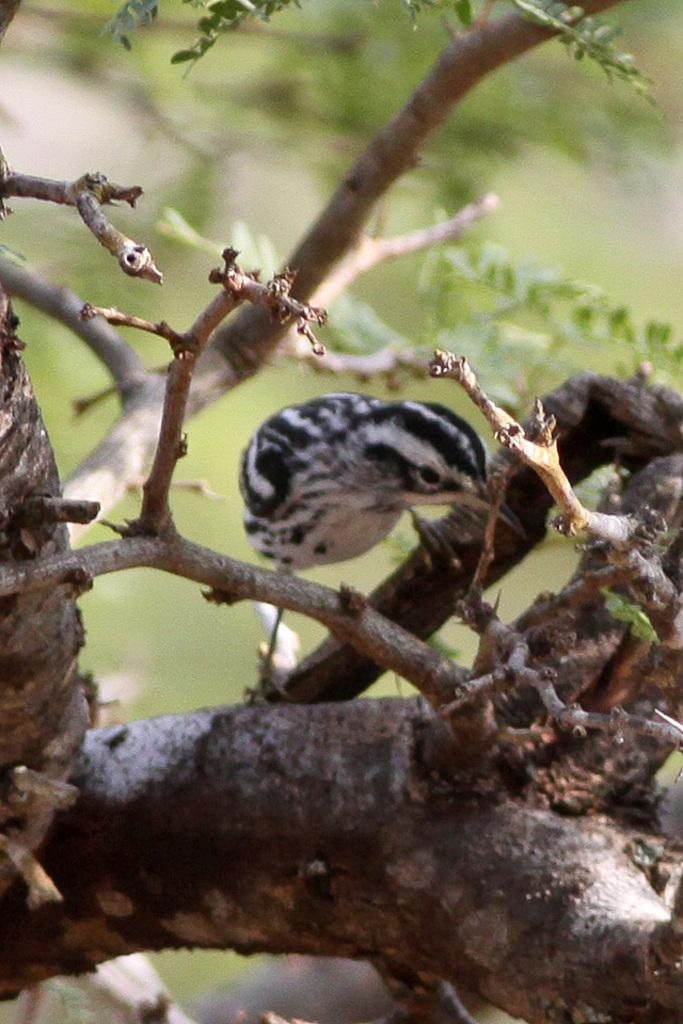What type of animal is in the image? There is a bird in the image. What colors can be seen on the bird? The bird is black and white. Where is the bird located in the image? The bird is on a tree branch. What can be observed about the background of the image? The background of the image is blurred, and the background color is green. Can you see a baseball being played in the image? There is no baseball or any indication of a game being played in the image; it features a bird on a tree branch. What is the bird doing on top of the drain in the image? There is no drain present in the image, and the bird is on a tree branch, not on a drain. 